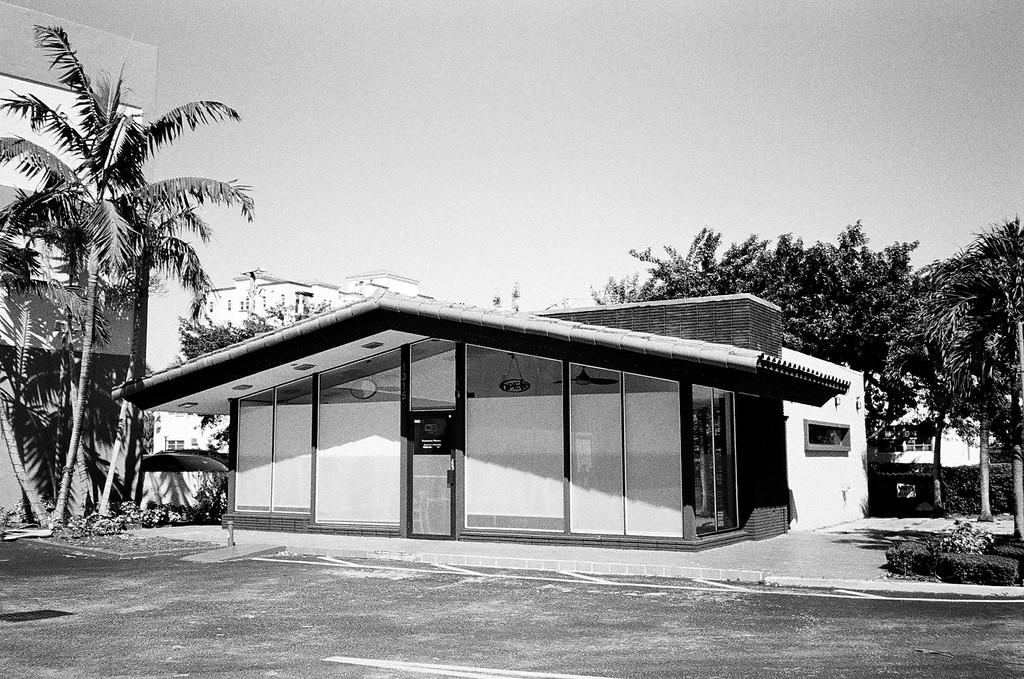What is the color scheme of the image? The image is black and white. What type of structures can be seen in the image? There are buildings in the image. What other natural elements are present in the image? There are trees in the image. What is visible at the top of the image? The sky is visible at the top of the image. Can you see any mountains in the image? There are no mountains visible in the image; it features buildings, trees, and a sky. What type of nut is being used to hold the buildings together in the image? There are no nuts present in the image, as it is a black and white image of buildings, trees, and a sky. 